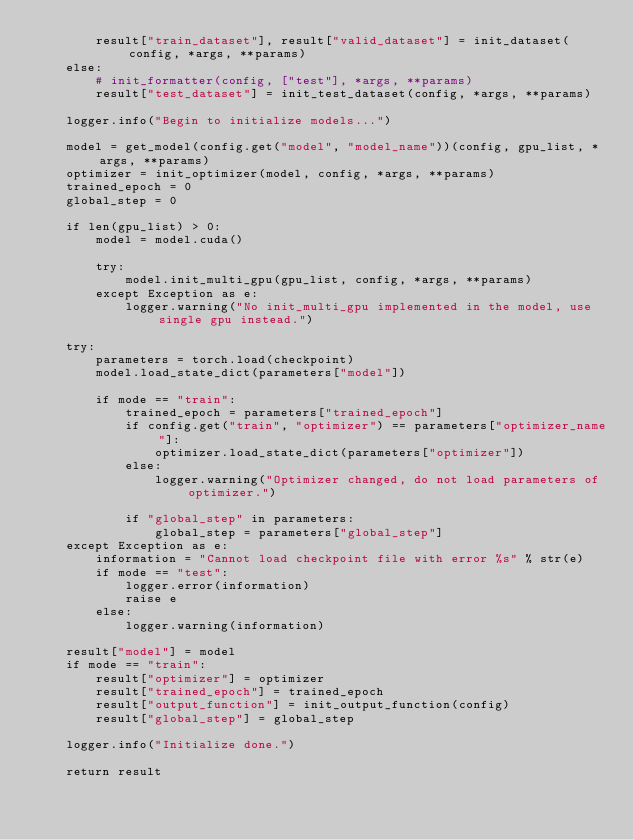Convert code to text. <code><loc_0><loc_0><loc_500><loc_500><_Python_>        result["train_dataset"], result["valid_dataset"] = init_dataset(config, *args, **params)
    else:
        # init_formatter(config, ["test"], *args, **params)
        result["test_dataset"] = init_test_dataset(config, *args, **params)

    logger.info("Begin to initialize models...")

    model = get_model(config.get("model", "model_name"))(config, gpu_list, *args, **params)
    optimizer = init_optimizer(model, config, *args, **params)
    trained_epoch = 0
    global_step = 0

    if len(gpu_list) > 0:
        model = model.cuda()

        try:
            model.init_multi_gpu(gpu_list, config, *args, **params)
        except Exception as e:
            logger.warning("No init_multi_gpu implemented in the model, use single gpu instead.")

    try:
        parameters = torch.load(checkpoint)
        model.load_state_dict(parameters["model"])

        if mode == "train":
            trained_epoch = parameters["trained_epoch"]
            if config.get("train", "optimizer") == parameters["optimizer_name"]:
                optimizer.load_state_dict(parameters["optimizer"])
            else:
                logger.warning("Optimizer changed, do not load parameters of optimizer.")

            if "global_step" in parameters:
                global_step = parameters["global_step"]
    except Exception as e:
        information = "Cannot load checkpoint file with error %s" % str(e)
        if mode == "test":
            logger.error(information)
            raise e
        else:
            logger.warning(information)

    result["model"] = model
    if mode == "train":
        result["optimizer"] = optimizer
        result["trained_epoch"] = trained_epoch
        result["output_function"] = init_output_function(config)
        result["global_step"] = global_step

    logger.info("Initialize done.")

    return result
</code> 